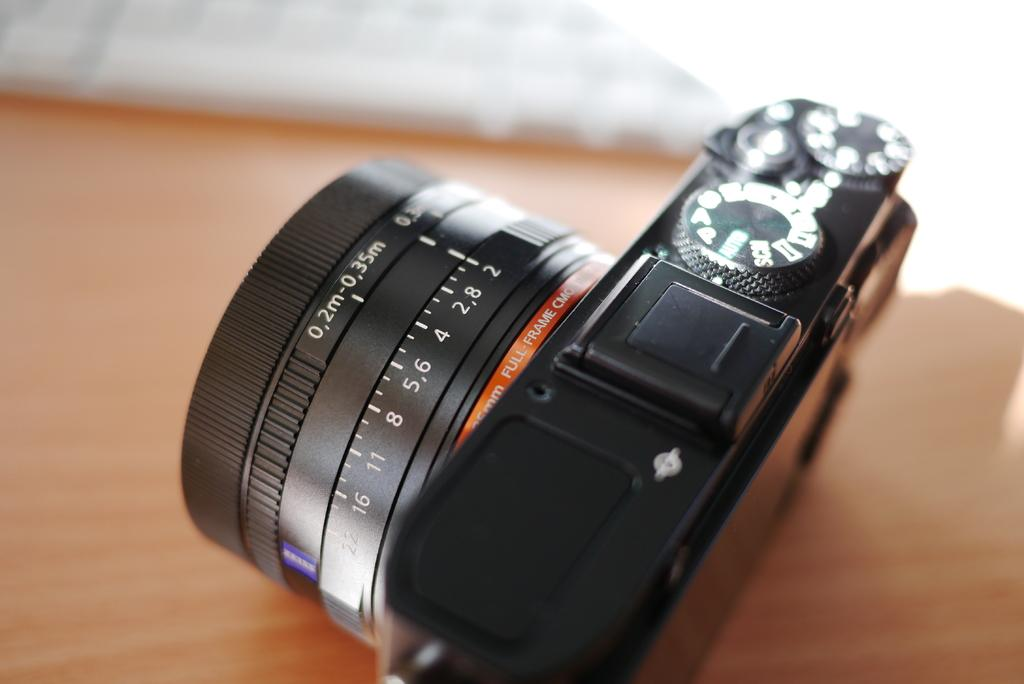<image>
Render a clear and concise summary of the photo. A camera with full-frame CMO is sitting on a wooden table. 